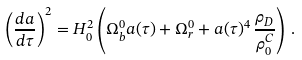<formula> <loc_0><loc_0><loc_500><loc_500>\left ( \frac { d a } { d \tau } \right ) ^ { 2 } = H _ { 0 } ^ { 2 } \left ( \Omega ^ { 0 } _ { b } a ( \tau ) + \Omega ^ { 0 } _ { r } + a ( \tau ) ^ { 4 } \, \frac { \rho _ { D } } { \rho _ { 0 } ^ { C } } \right ) \, .</formula> 